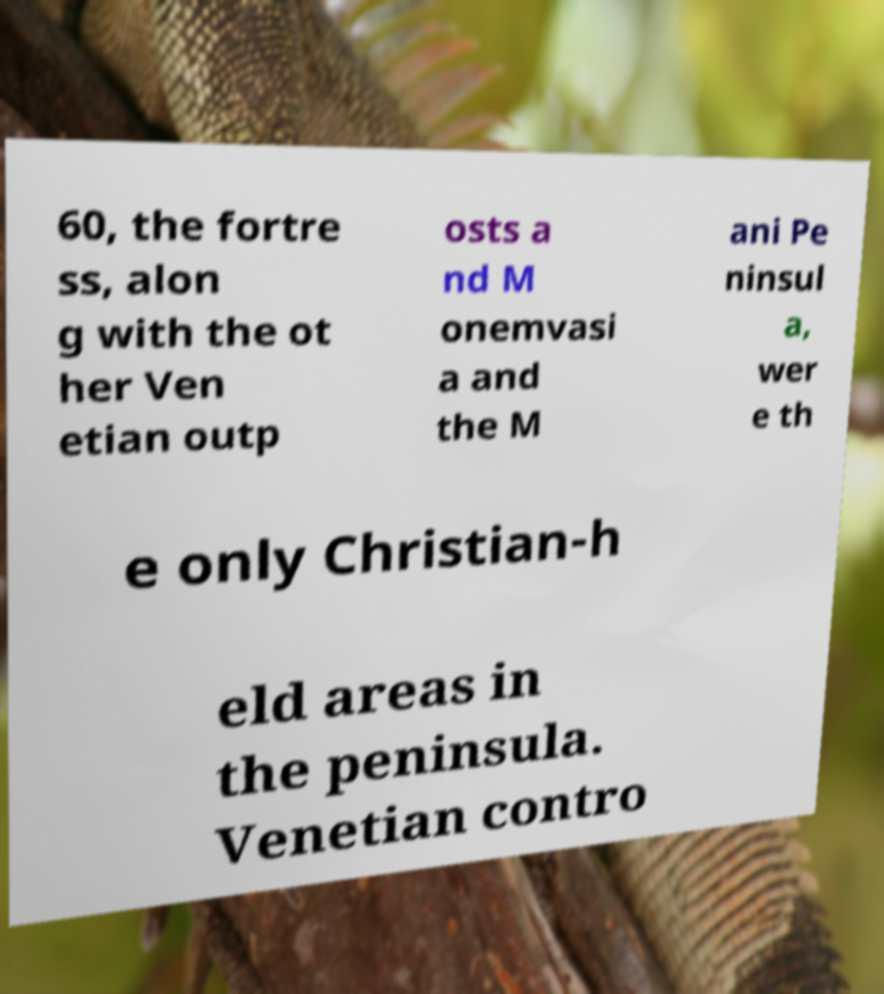Can you read and provide the text displayed in the image?This photo seems to have some interesting text. Can you extract and type it out for me? 60, the fortre ss, alon g with the ot her Ven etian outp osts a nd M onemvasi a and the M ani Pe ninsul a, wer e th e only Christian-h eld areas in the peninsula. Venetian contro 